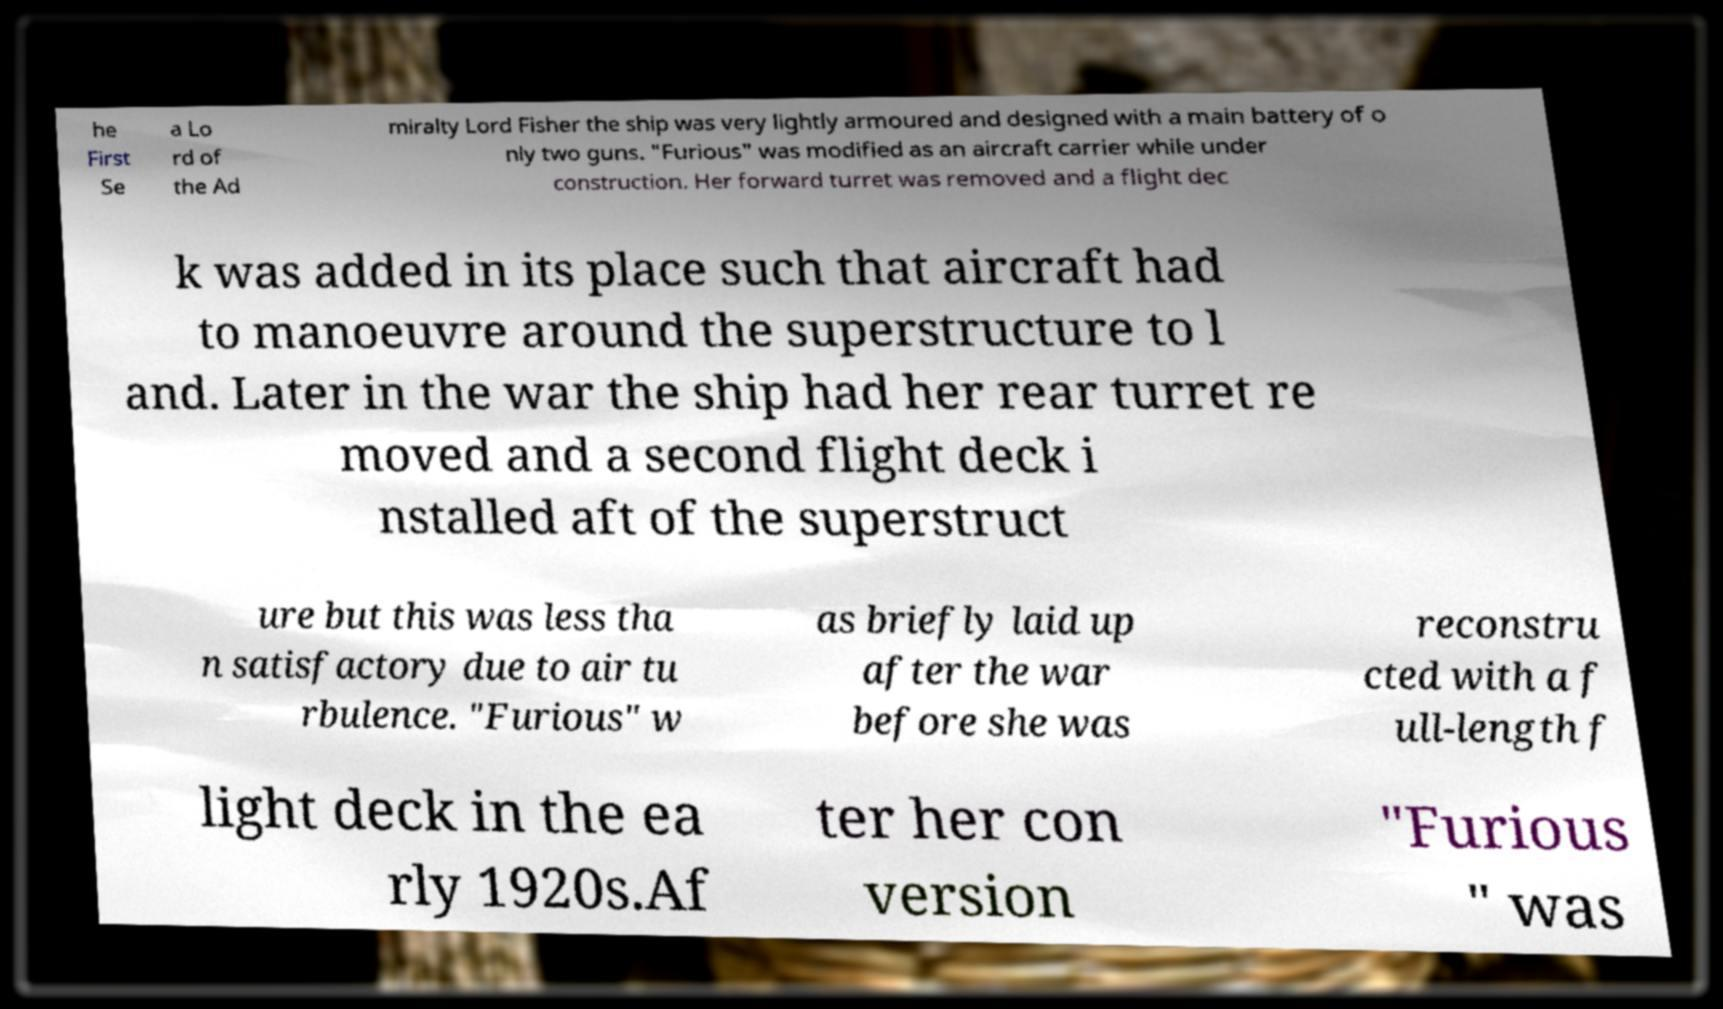What messages or text are displayed in this image? I need them in a readable, typed format. he First Se a Lo rd of the Ad miralty Lord Fisher the ship was very lightly armoured and designed with a main battery of o nly two guns. "Furious" was modified as an aircraft carrier while under construction. Her forward turret was removed and a flight dec k was added in its place such that aircraft had to manoeuvre around the superstructure to l and. Later in the war the ship had her rear turret re moved and a second flight deck i nstalled aft of the superstruct ure but this was less tha n satisfactory due to air tu rbulence. "Furious" w as briefly laid up after the war before she was reconstru cted with a f ull-length f light deck in the ea rly 1920s.Af ter her con version "Furious " was 